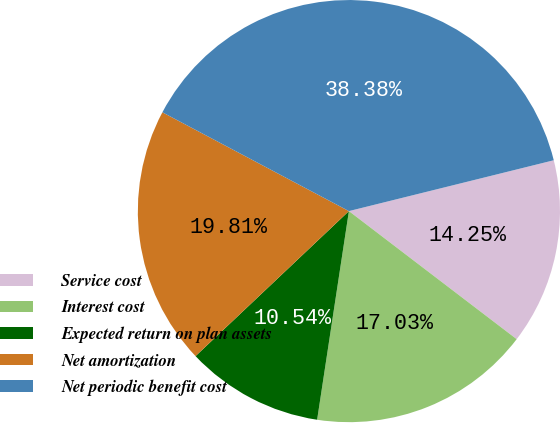Convert chart. <chart><loc_0><loc_0><loc_500><loc_500><pie_chart><fcel>Service cost<fcel>Interest cost<fcel>Expected return on plan assets<fcel>Net amortization<fcel>Net periodic benefit cost<nl><fcel>14.25%<fcel>17.03%<fcel>10.54%<fcel>19.81%<fcel>38.38%<nl></chart> 